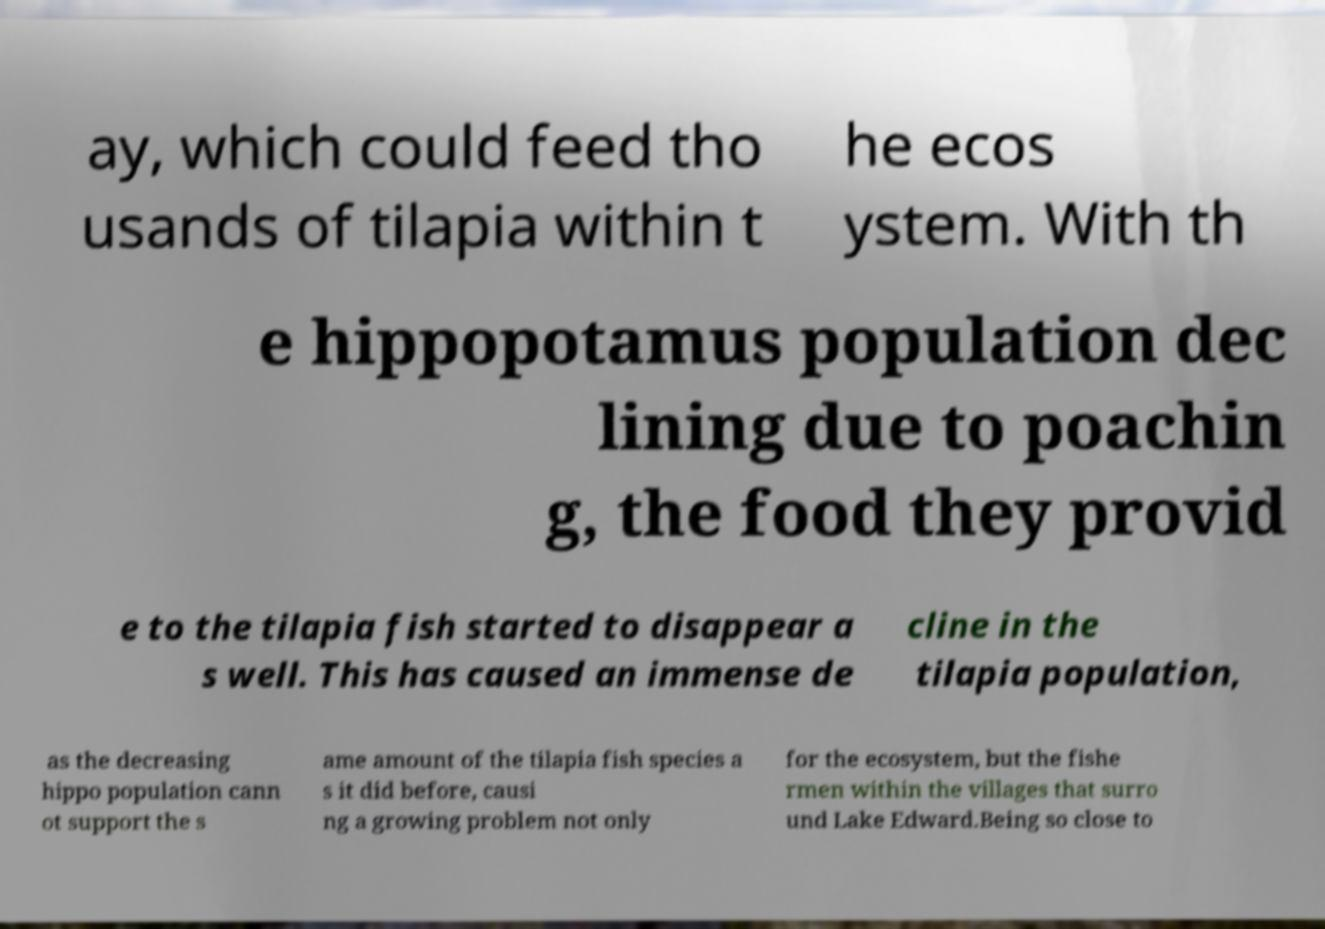Could you assist in decoding the text presented in this image and type it out clearly? ay, which could feed tho usands of tilapia within t he ecos ystem. With th e hippopotamus population dec lining due to poachin g, the food they provid e to the tilapia fish started to disappear a s well. This has caused an immense de cline in the tilapia population, as the decreasing hippo population cann ot support the s ame amount of the tilapia fish species a s it did before, causi ng a growing problem not only for the ecosystem, but the fishe rmen within the villages that surro und Lake Edward.Being so close to 